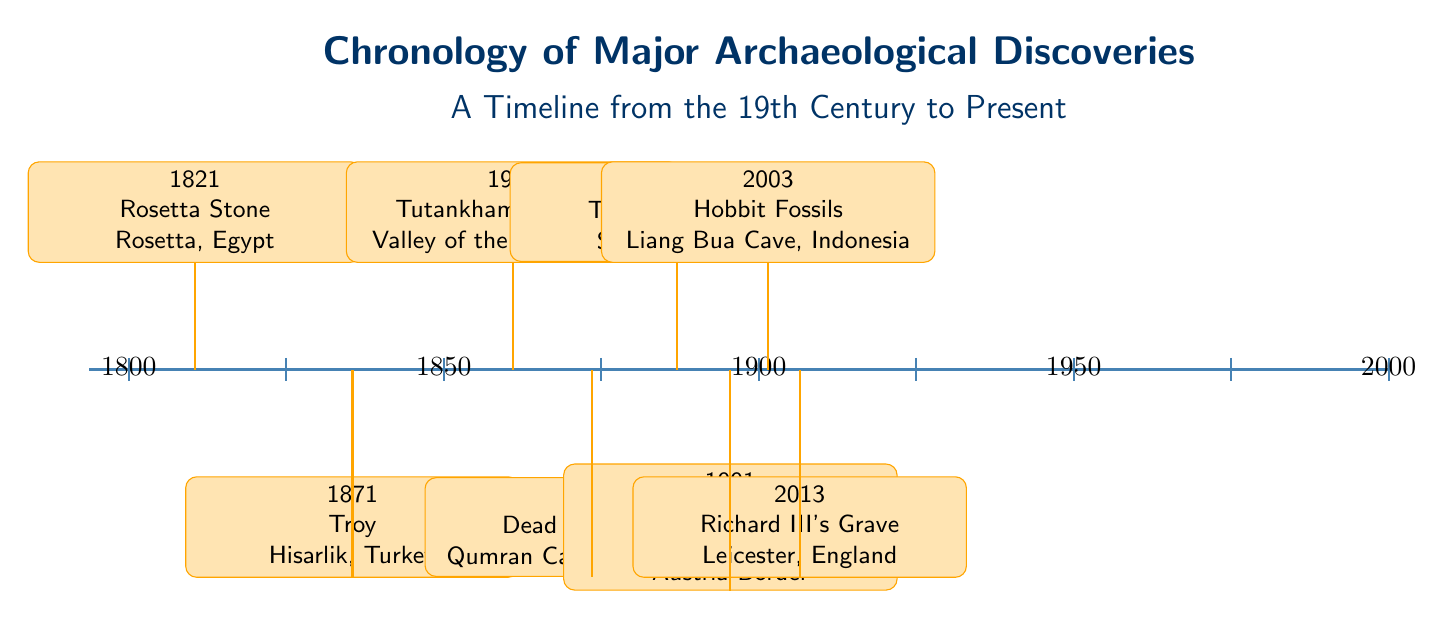What year was the Rosetta Stone discovered? The diagram contains an event labeled "Rosetta Stone" at the year 1821. The specific node for this event indicates the discovery date clearly.
Answer: 1821 How many major archaeological discoveries are listed on the timeline? By counting the individual events represented as nodes on the timeline, there are a total of eight discoveries depicted in the diagram.
Answer: 8 Which discovery occurred in 1947? The timeline indicates that the event labeled "Dead Sea Scrolls" is positioned at the year 1947, directly confirming the discovery corresponding to that year.
Answer: Dead Sea Scrolls What was discovered in 2003? The diagram specifies the event "Hobbit Fossils" occurring in the year 2003, allowing us to identify this discovery easily from the information presented.
Answer: Hobbit Fossils Which discovery comes immediately after the Terracotta Army? In analyzing the timeline, the event that follows the "Terracotta Army," which is noted at 1974, is "Ötzi the Iceman" located at 1991. Thus, it directly correlates as the subsequent discovery.
Answer: Ötzi the Iceman In what country were the Tutankhamun's Tomb artifacts found? The diagram indicates that Tutankhamun's Tomb was discovered in "Valley of the Kings, Egypt," clearly associating the discovery with its geographical location.
Answer: Egypt What is the time span between the discovery of the Rosetta Stone and the Dead Sea Scrolls? The Rosetta Stone was discovered in 1821 and the Dead Sea Scrolls in 1947, thus calculating the time difference amounts to 1947 - 1821, resulting in a 126-year gap.
Answer: 126 years Which discovery is positioned at $(6.96,2)$ on the diagram? By locating the coordinates of $(6.96,2)$ on the diagram, it corresponds to the event "Terracotta Army," which is specifically labeled at that position.
Answer: Terracotta Army 